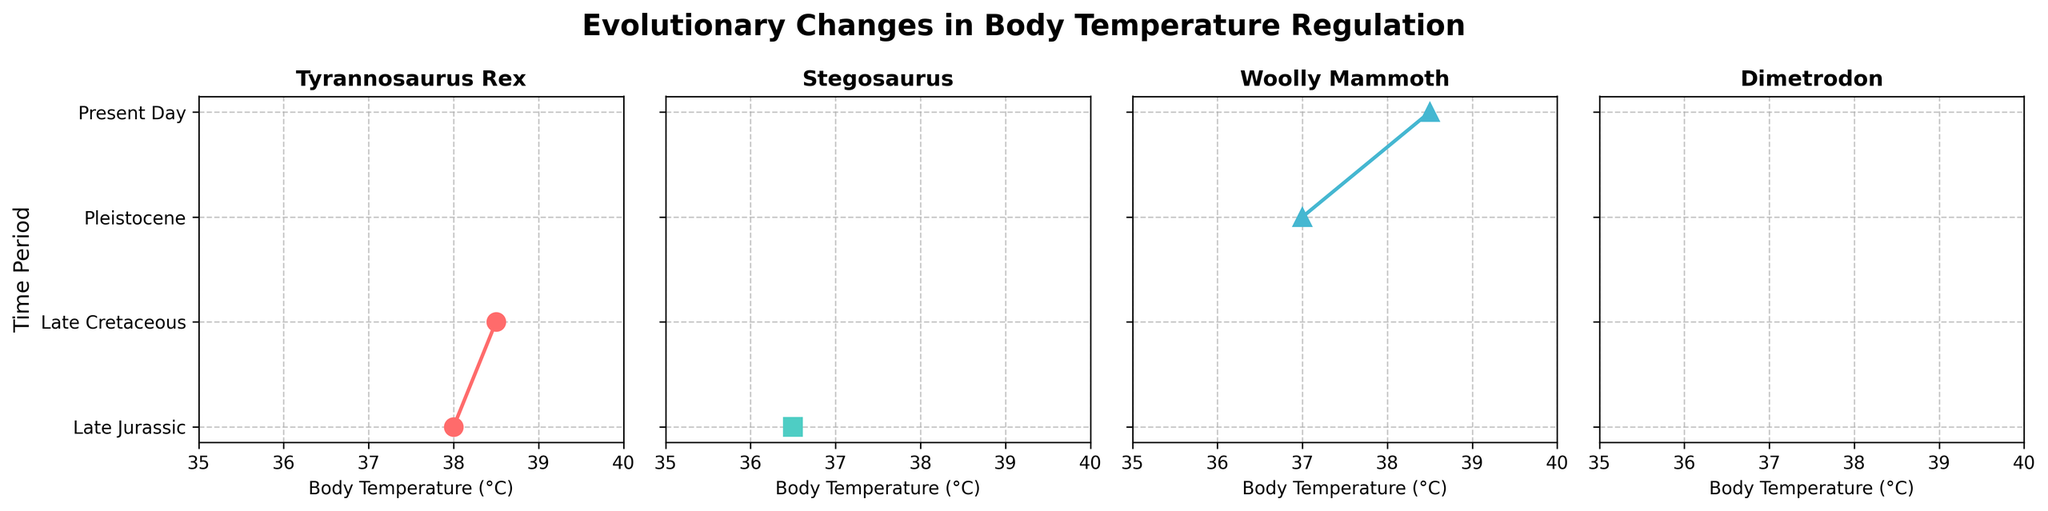What is the title of the figure? The title is displayed at the top of the figure and indicates the main topic being visualized. It is written in bold and large font size for emphasis.
Answer: Evolutionary Changes in Body Temperature Regulation Which creature's body temperature is shown for the time period "Pleistocene"? By looking at the Pleistocene row within all subplots, you will notice that only the Woolly Mammoth has a data point in this time period.
Answer: Woolly Mammoth What is the body temperature of the Tyrannosaurus Rex in the Late Jurassic period? Locate the Tyrannosaurus Rex subplot and find the temperature marked for the Late Jurassic period. This value is connected with a vertical line and a marker.
Answer: 38.0°C Compare the body temperatures of the Tyrannosaurus Rex in the Late Jurassic and Late Cretaceous periods. Which period had a higher temperature? In the Tyrannosaurus Rex subplot, compare the temperatures shown for the Late Jurassic and Late Cretaceous periods by looking at the position on the X-axis. The Late Cretaceous period value is higher.
Answer: Late Cretaceous How many time periods are represented in the entire figure? By counting all the distinct periods listed on the Y-axis, you can see the total number of unique time periods represented.
Answer: Four Which two creatures have their body temperature recorded only in one time period? Identify these creatures by checking which subplots have only one data point marked. The two creatures are Stegosaurus and Dimetrodon.
Answer: Stegosaurus and Dimetrodon What is the range of body temperatures displayed in the figure? The range can be determined by noting the minimum and maximum values across all subplots. The minimum is seen in the Stegosaurus (36.5°C), and the maximum is in all modern day animals (38.5°C).
Answer: 36.5°C to 38.5°C By how many degrees is the Woolly Mammoth's temperature in the Pleistocene lower than the modern-day value? Subtract the Woolly Mammoth's temperature in the Pleistocene (37.0°C) from the present-day value (38.5°C).
Answer: 1.5°C Which creature's subplot utilizes the marker shape 's'? By associating each subplot's marker shape with the legend provided in the problem, you can determine that Stegosaurus uses the marker 's'.
Answer: Stegosaurus 